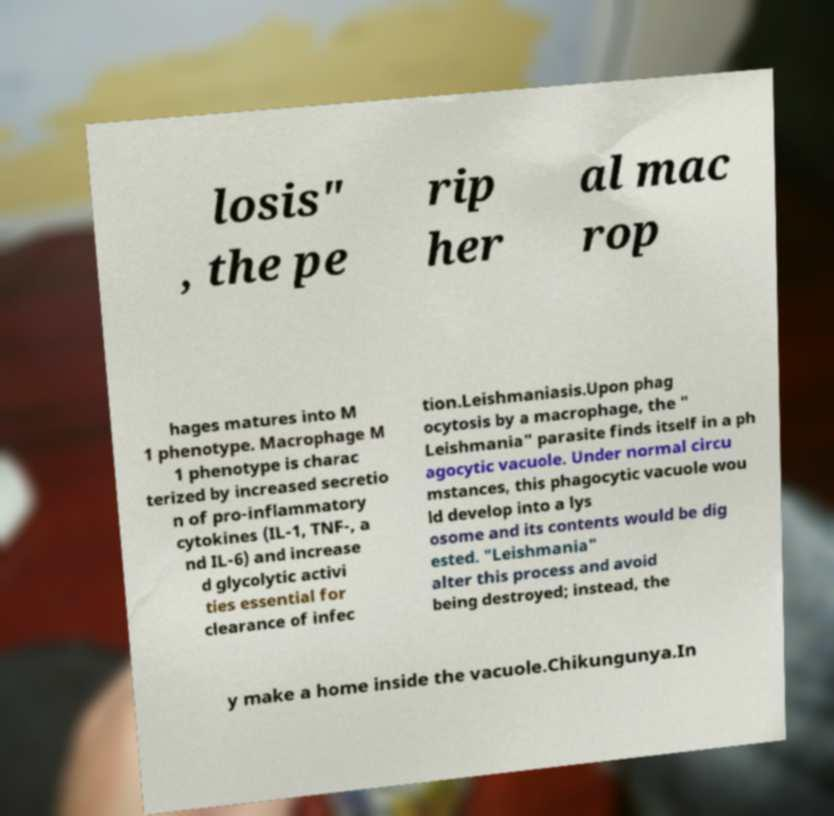There's text embedded in this image that I need extracted. Can you transcribe it verbatim? losis" , the pe rip her al mac rop hages matures into M 1 phenotype. Macrophage M 1 phenotype is charac terized by increased secretio n of pro-inflammatory cytokines (IL-1, TNF-, a nd IL-6) and increase d glycolytic activi ties essential for clearance of infec tion.Leishmaniasis.Upon phag ocytosis by a macrophage, the " Leishmania" parasite finds itself in a ph agocytic vacuole. Under normal circu mstances, this phagocytic vacuole wou ld develop into a lys osome and its contents would be dig ested. "Leishmania" alter this process and avoid being destroyed; instead, the y make a home inside the vacuole.Chikungunya.In 